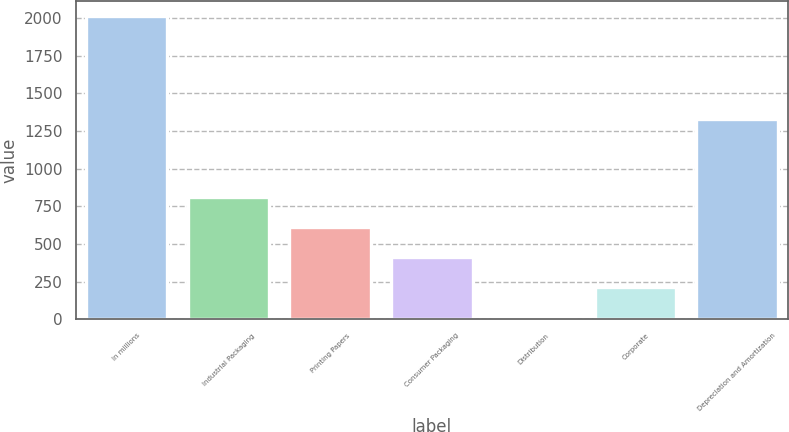<chart> <loc_0><loc_0><loc_500><loc_500><bar_chart><fcel>In millions<fcel>Industrial Packaging<fcel>Printing Papers<fcel>Consumer Packaging<fcel>Distribution<fcel>Corporate<fcel>Depreciation and Amortization<nl><fcel>2011<fcel>812.8<fcel>613.1<fcel>413.4<fcel>14<fcel>213.7<fcel>1332<nl></chart> 